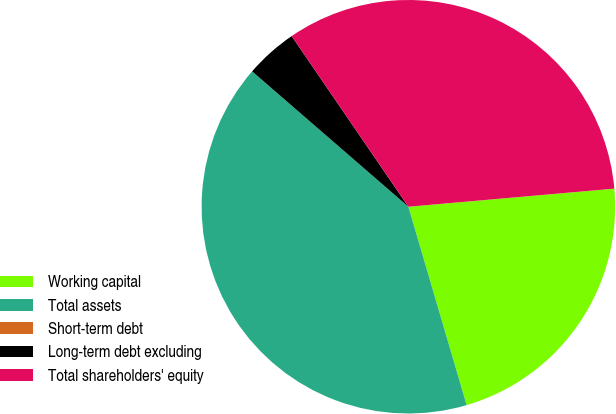Convert chart. <chart><loc_0><loc_0><loc_500><loc_500><pie_chart><fcel>Working capital<fcel>Total assets<fcel>Short-term debt<fcel>Long-term debt excluding<fcel>Total shareholders' equity<nl><fcel>21.85%<fcel>40.91%<fcel>0.0%<fcel>4.09%<fcel>33.15%<nl></chart> 